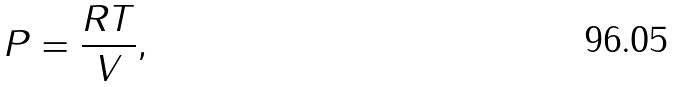<formula> <loc_0><loc_0><loc_500><loc_500>P = \frac { R T } { V } ,</formula> 